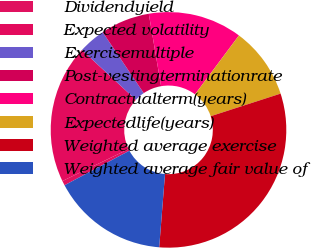Convert chart to OTSL. <chart><loc_0><loc_0><loc_500><loc_500><pie_chart><fcel>Dividendyield<fcel>Expected volatility<fcel>Exercisemultiple<fcel>Post-vestingterminationrate<fcel>Contractualterm(years)<fcel>Expectedlife(years)<fcel>Weighted average exercise<fcel>Weighted average fair value of<nl><fcel>0.64%<fcel>19.01%<fcel>3.7%<fcel>6.76%<fcel>12.88%<fcel>9.82%<fcel>31.24%<fcel>15.95%<nl></chart> 